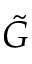<formula> <loc_0><loc_0><loc_500><loc_500>\tilde { G }</formula> 